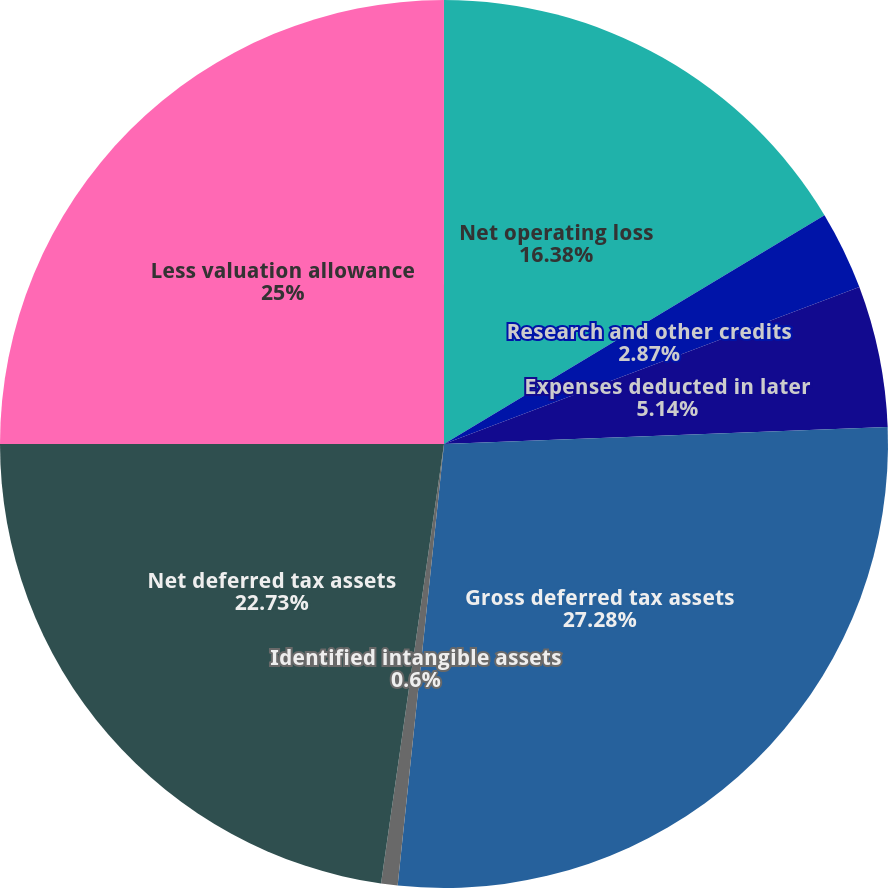Convert chart. <chart><loc_0><loc_0><loc_500><loc_500><pie_chart><fcel>Net operating loss<fcel>Research and other credits<fcel>Expenses deducted in later<fcel>Gross deferred tax assets<fcel>Identified intangible assets<fcel>Net deferred tax assets<fcel>Less valuation allowance<nl><fcel>16.38%<fcel>2.87%<fcel>5.14%<fcel>27.27%<fcel>0.6%<fcel>22.73%<fcel>25.0%<nl></chart> 